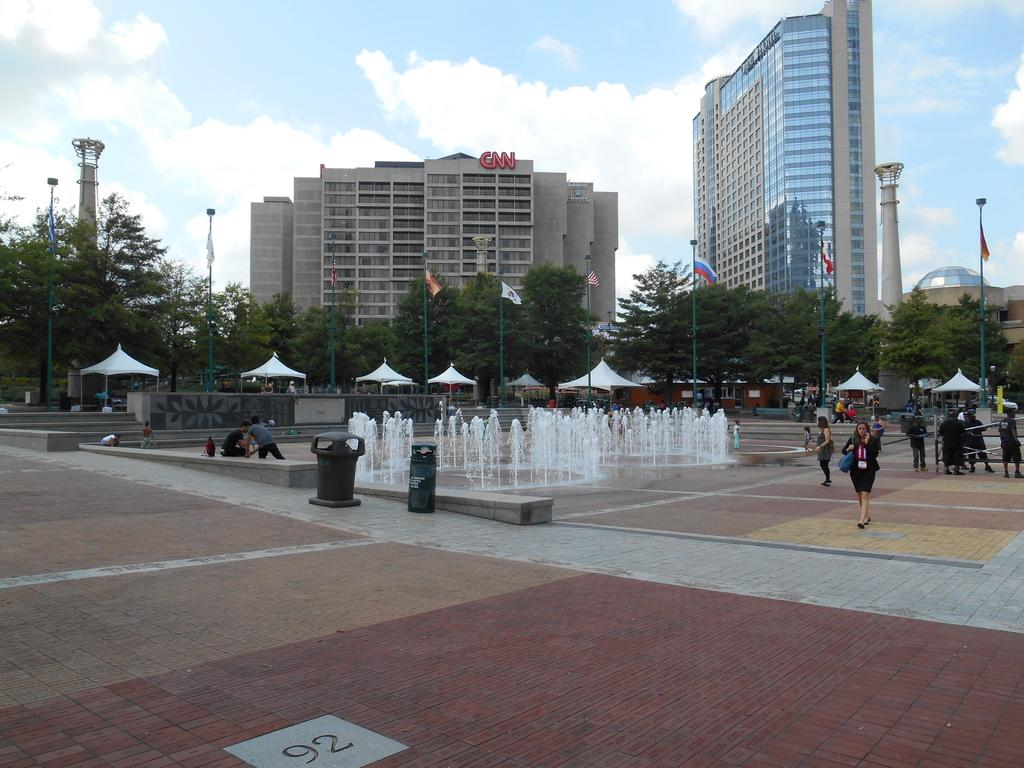How many people can be seen in the image? There are people in the image. What objects are present on the path in the image? There are dust bins on the path in the image. What feature is present for people to get water in the image? There is a water fountain in the image. What structures are present for displaying flags in the image? There are flag poles in the image. What temporary shelters can be seen in the image? There are tents in the image. What type of vegetation is present in the image? There are trees in the image. What type of man-made structures can be seen in the image? There are buildings in the image. What part of the natural environment is visible in the background of the image? The sky is visible in the background of the image. How many bikes are parked near the water fountain in the image? There is no mention of bikes in the image, so it is not possible to determine how many might be parked near the water fountain. What type of man can be seen interacting with the flag poles in the image? There is no mention of a man interacting with the flag poles in the image, so it is not possible to describe his actions or appearance. 